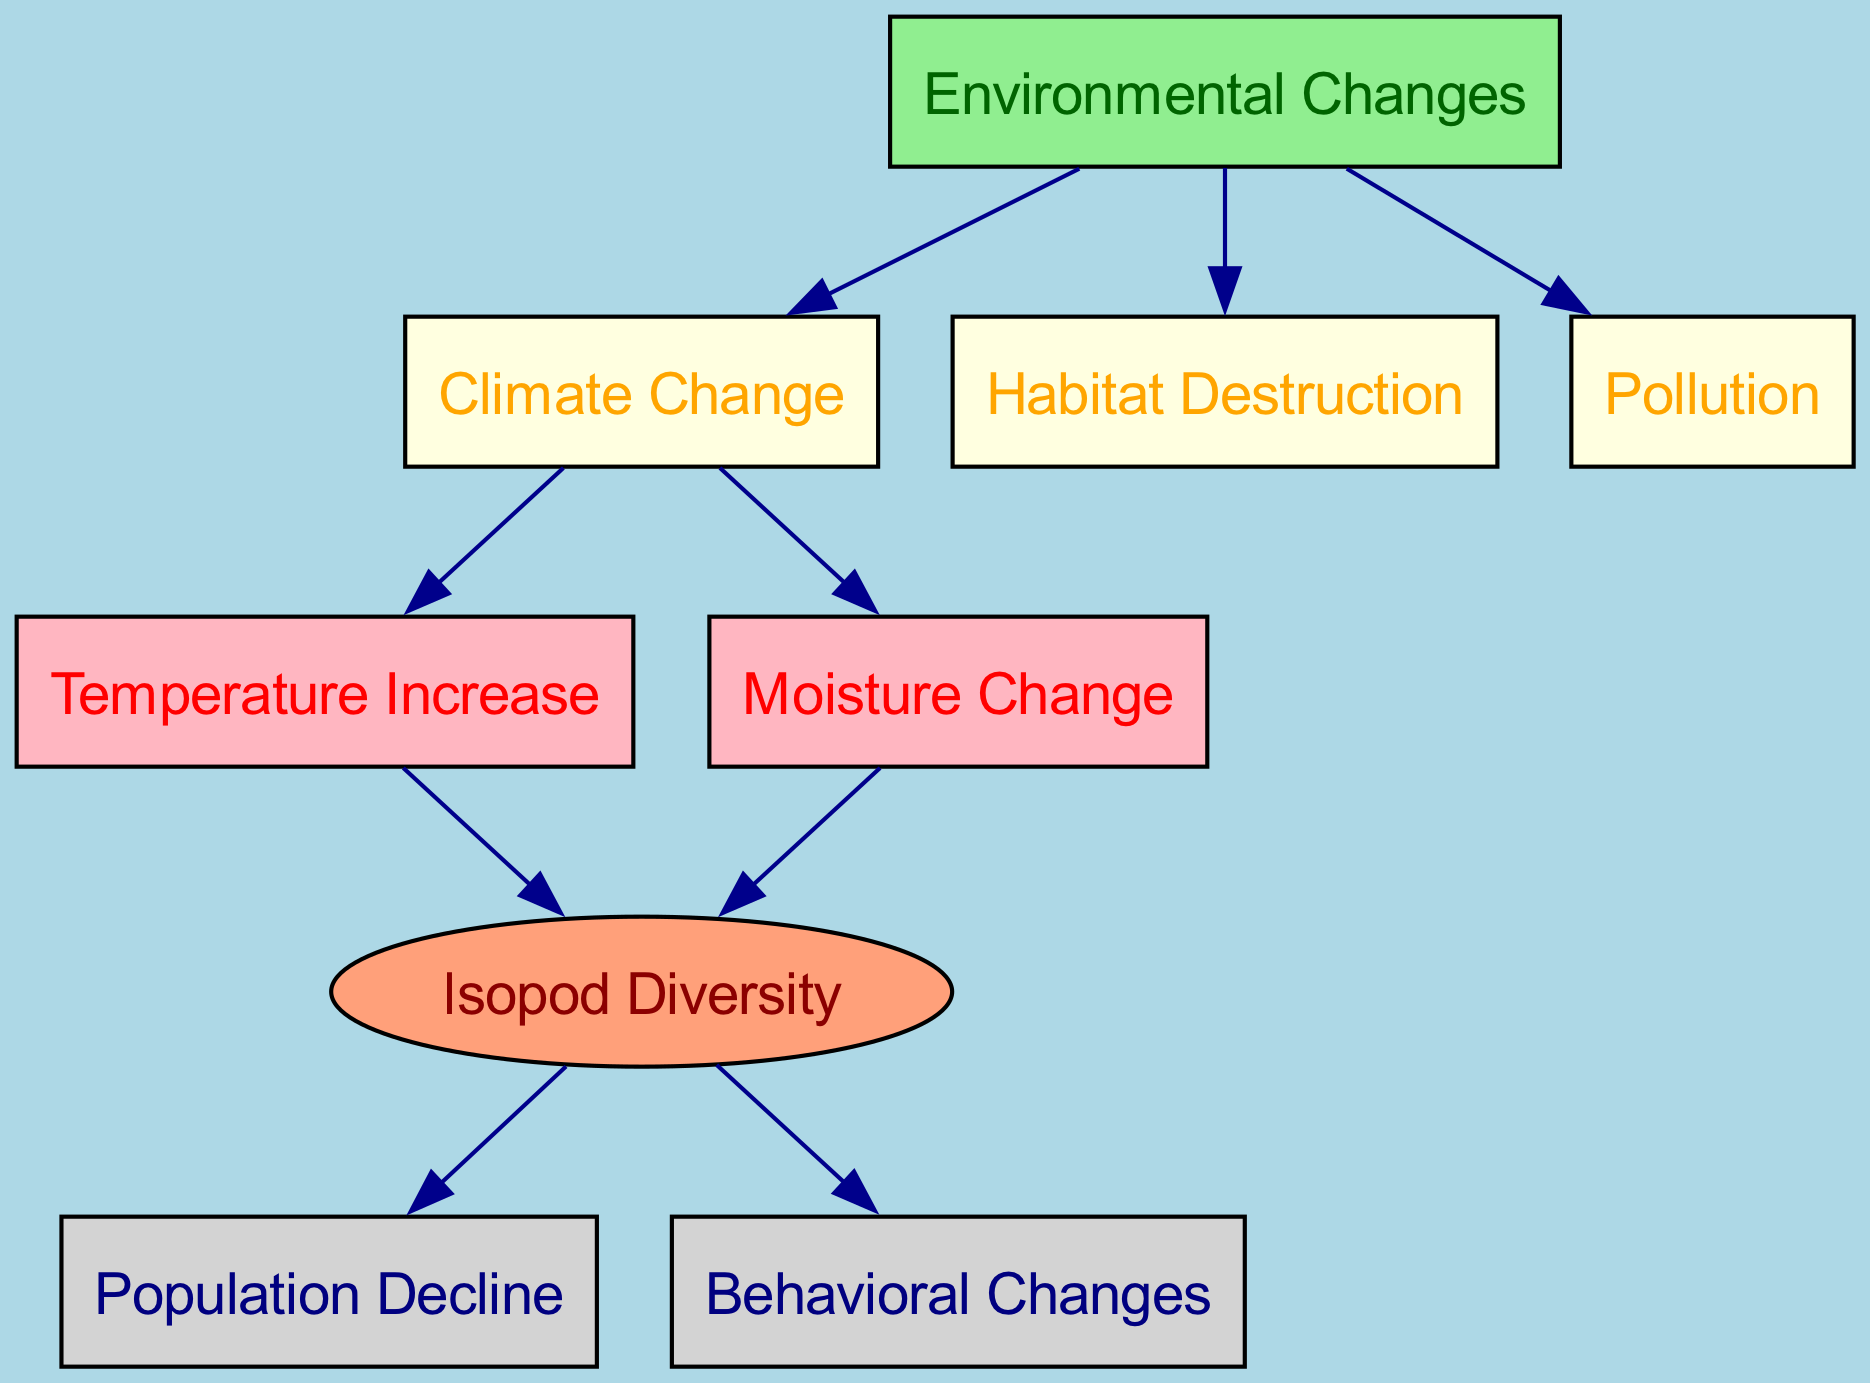What is the main category of factors influencing isopod populations? The diagram starts with a node labeled "Environmental Changes," which serves as the primary factor affecting isopod populations. This node connects to various specific environmental factors.
Answer: Environmental Changes How many edges connect to the "Climate Change" node? The "Climate Change" node has two outgoing edges leading to "Temperature Increase" and "Moisture Change." This can be counted directly from the directed diagram connections.
Answer: 2 What is the relationship between "Temperature Increase" and "Isopod Diversity"? The "Temperature Increase" node has a directed edge that leads to the "Isopod Diversity" node, indicating that temperature increases directly influence or affect isopod diversity.
Answer: Influences Name one consequence of decreased "Isopod Diversity." The diagram shows that "Isopod Diversity" leads to two nodes: "Population Decline" and "Behavioral Changes." Therefore, a decrease in isopod diversity results in population decline or altered behaviors.
Answer: Population Decline Which environmental change is directly linked to both "Temperature Increase" and "Moisture Change"? By examining the diagram, "Climate Change" is the node that connects directly to both "Temperature Increase" and "Moisture Change," serving as the common factor for these changes.
Answer: Climate Change What can lead to "Behavioral Changes" in isopods according to the diagram? "Isopod Diversity" is the only node that has a direct edge leading to "Behavioral Changes." Thus, changes in isopod diversity can lead to behavioral changes.
Answer: Isopod Diversity How many types of environmental changes are listed in the diagram? The diagram includes three types of environmental changes: "Climate Change," "Habitat Destruction," and "Pollution." These can be tallied as they each connect from the "Environmental Changes" node.
Answer: 3 If "Moisture Change" affects isopod diversity, what might be the potential outcome? "Moisture Change" has an outgoing edge to "Isopod Diversity," which in turn connects to both "Population Decline" and "Behavioral Changes." This suggests that changes in moisture can lead to declines in populations or behavioral shifts.
Answer: Population Decline and Behavioral Changes Which factor has a direct influence on both the population decline and behavioral changes of isopods? The node "Isopod Diversity" influences both "Population Decline" and "Behavioral Changes," as it has directed edges leading to these two outcomes, making it the factor that connects both consequences.
Answer: Isopod Diversity 